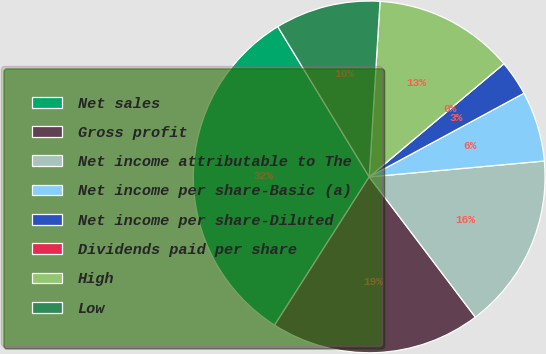<chart> <loc_0><loc_0><loc_500><loc_500><pie_chart><fcel>Net sales<fcel>Gross profit<fcel>Net income attributable to The<fcel>Net income per share-Basic (a)<fcel>Net income per share-Diluted<fcel>Dividends paid per share<fcel>High<fcel>Low<nl><fcel>32.26%<fcel>19.35%<fcel>16.13%<fcel>6.45%<fcel>3.23%<fcel>0.0%<fcel>12.9%<fcel>9.68%<nl></chart> 